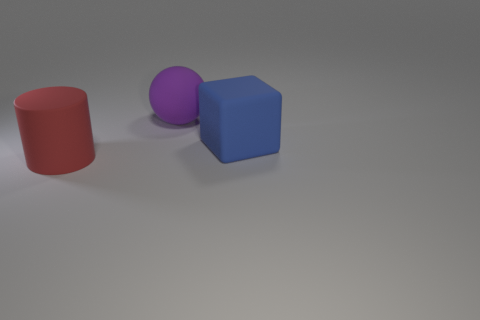What could be the possible use of these objects in a learning environment? These objects could serve as practical tools for teaching basic geometry and color recognition. For example, a teacher might use them to introduce students to the concepts of cylinders, spheres, and cubes, as well as to discuss primary and secondary colors. 